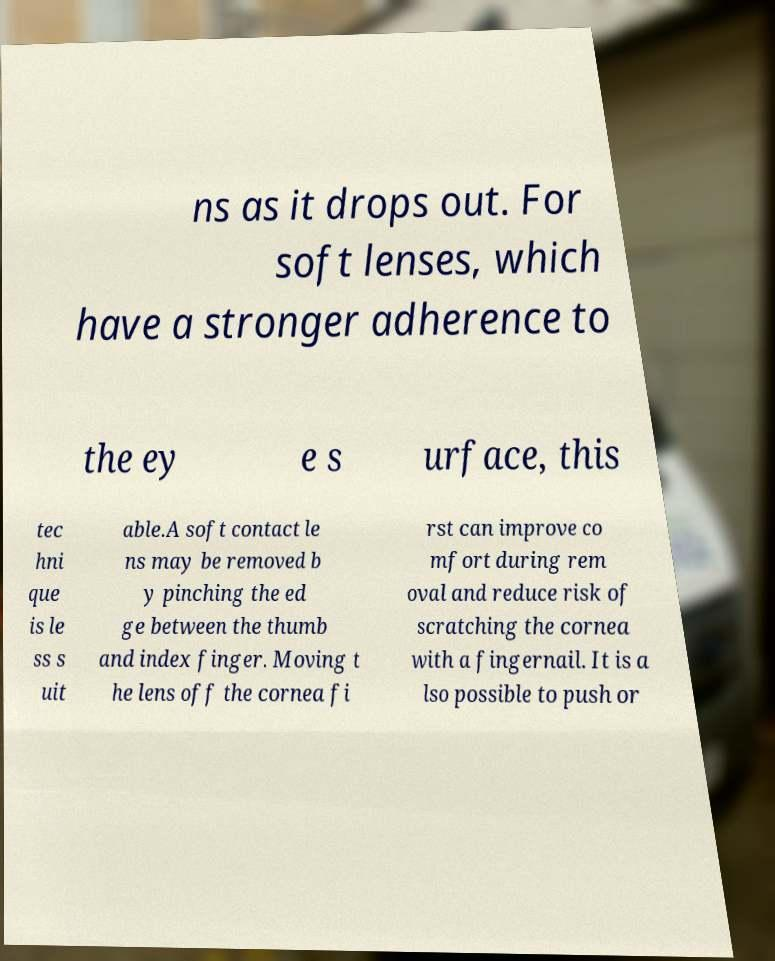Can you read and provide the text displayed in the image?This photo seems to have some interesting text. Can you extract and type it out for me? ns as it drops out. For soft lenses, which have a stronger adherence to the ey e s urface, this tec hni que is le ss s uit able.A soft contact le ns may be removed b y pinching the ed ge between the thumb and index finger. Moving t he lens off the cornea fi rst can improve co mfort during rem oval and reduce risk of scratching the cornea with a fingernail. It is a lso possible to push or 